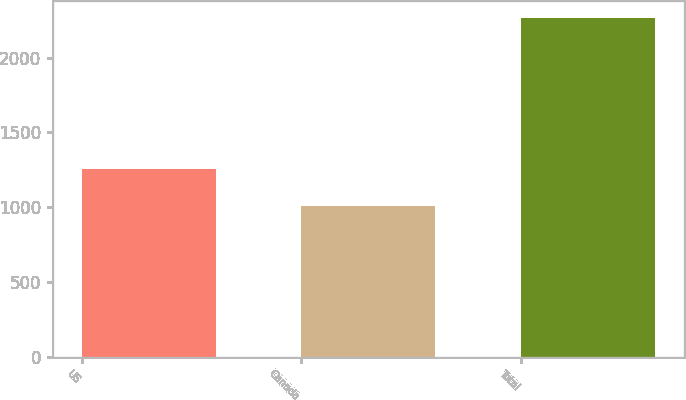Convert chart to OTSL. <chart><loc_0><loc_0><loc_500><loc_500><bar_chart><fcel>US<fcel>Canada<fcel>Total<nl><fcel>1257<fcel>1011<fcel>2268<nl></chart> 